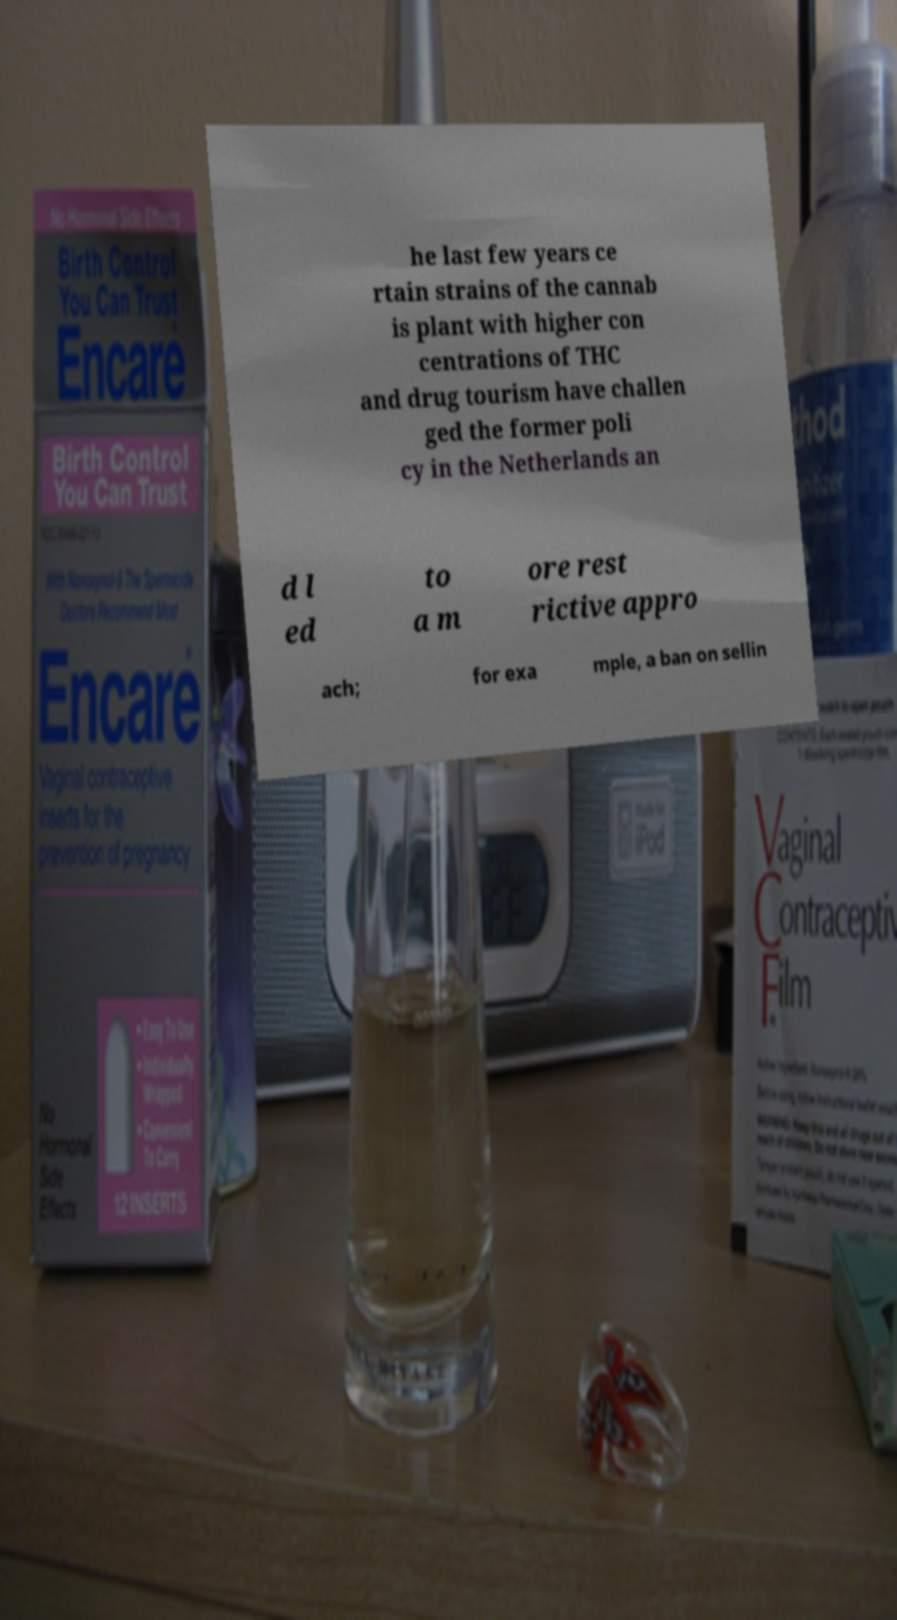I need the written content from this picture converted into text. Can you do that? he last few years ce rtain strains of the cannab is plant with higher con centrations of THC and drug tourism have challen ged the former poli cy in the Netherlands an d l ed to a m ore rest rictive appro ach; for exa mple, a ban on sellin 